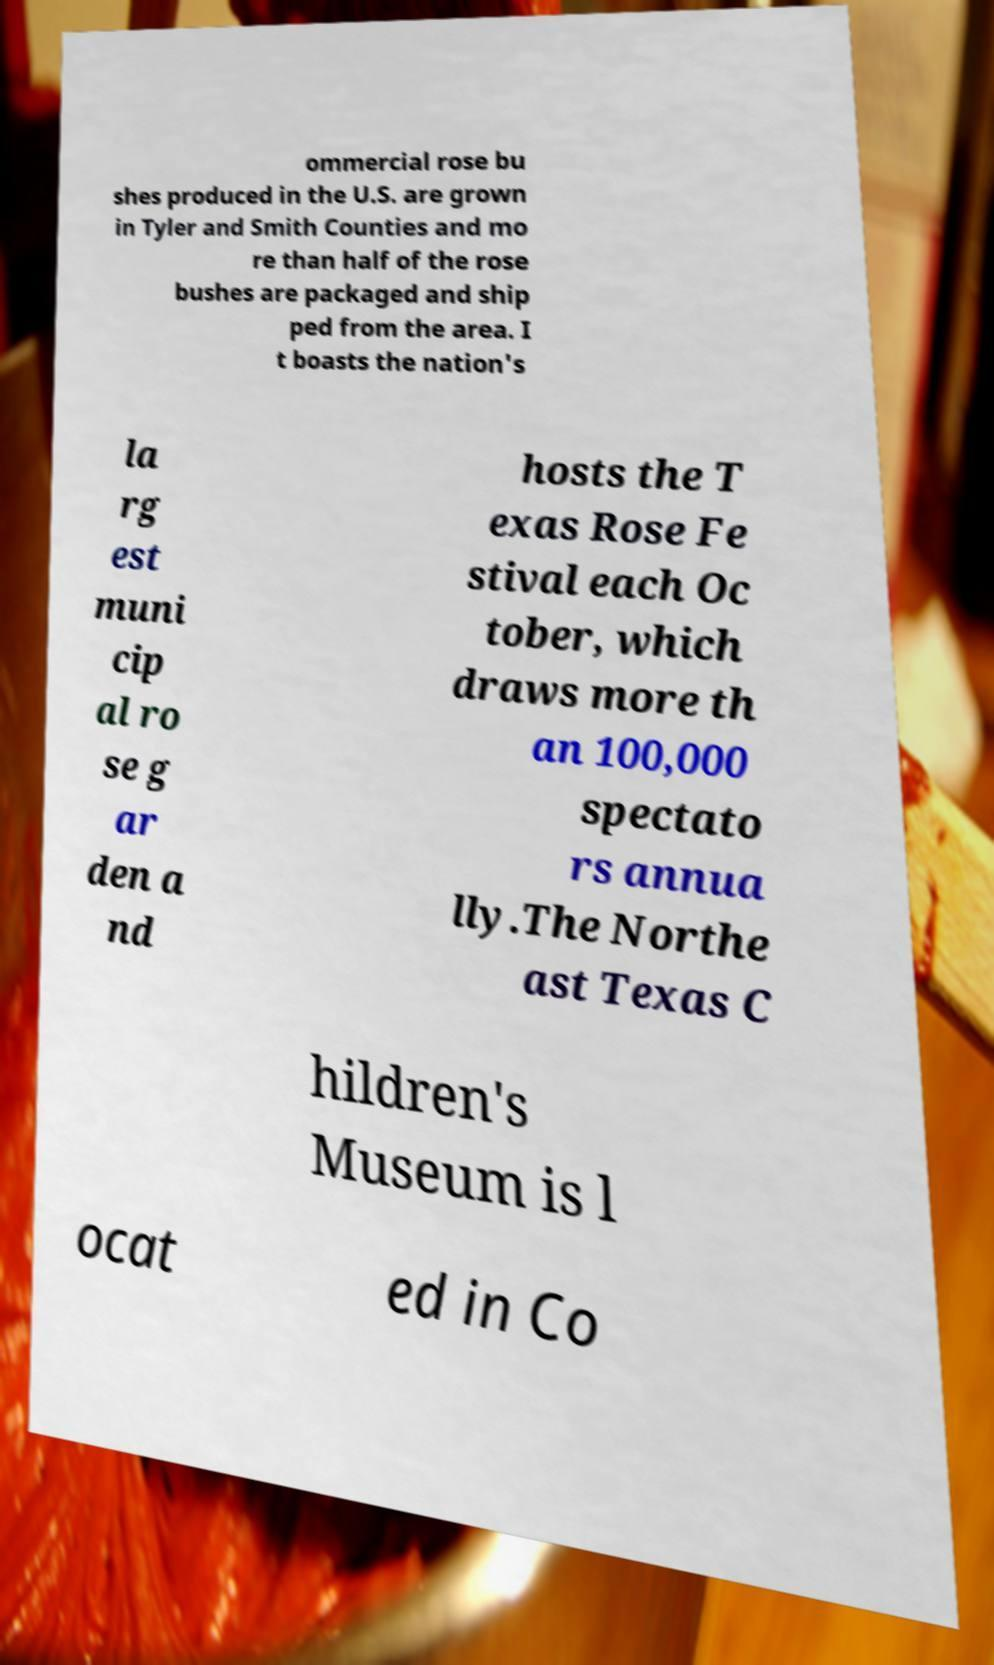I need the written content from this picture converted into text. Can you do that? ommercial rose bu shes produced in the U.S. are grown in Tyler and Smith Counties and mo re than half of the rose bushes are packaged and ship ped from the area. I t boasts the nation's la rg est muni cip al ro se g ar den a nd hosts the T exas Rose Fe stival each Oc tober, which draws more th an 100,000 spectato rs annua lly.The Northe ast Texas C hildren's Museum is l ocat ed in Co 